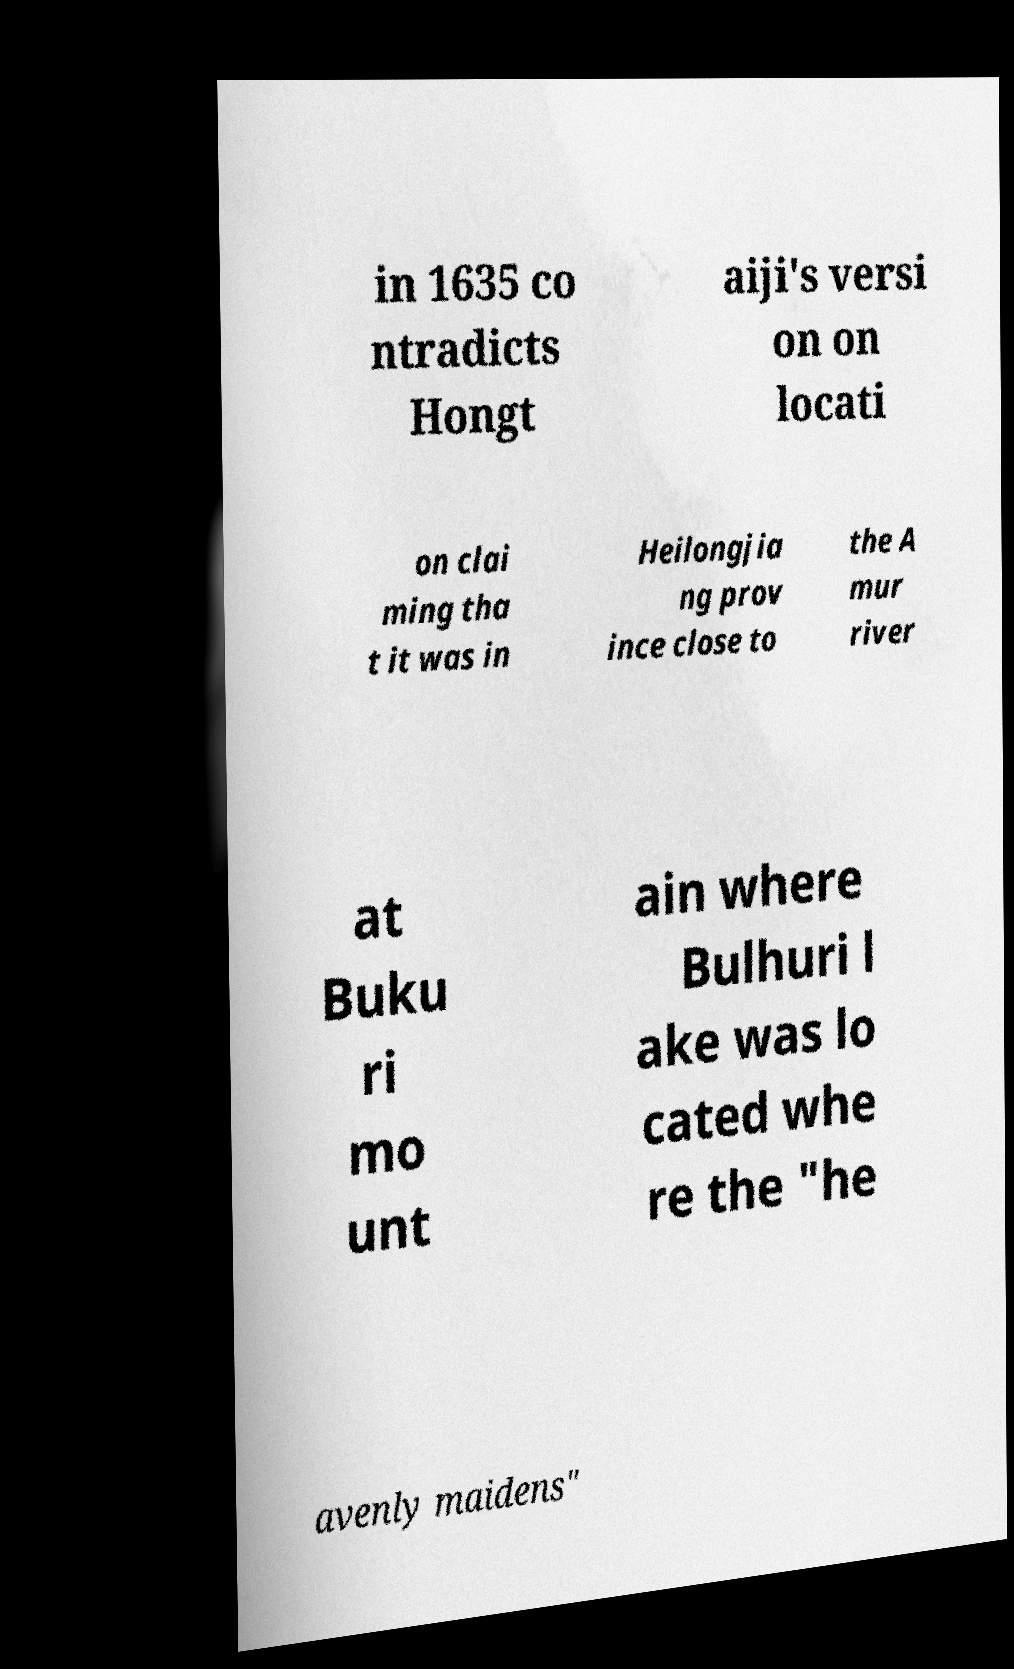What messages or text are displayed in this image? I need them in a readable, typed format. in 1635 co ntradicts Hongt aiji's versi on on locati on clai ming tha t it was in Heilongjia ng prov ince close to the A mur river at Buku ri mo unt ain where Bulhuri l ake was lo cated whe re the "he avenly maidens" 